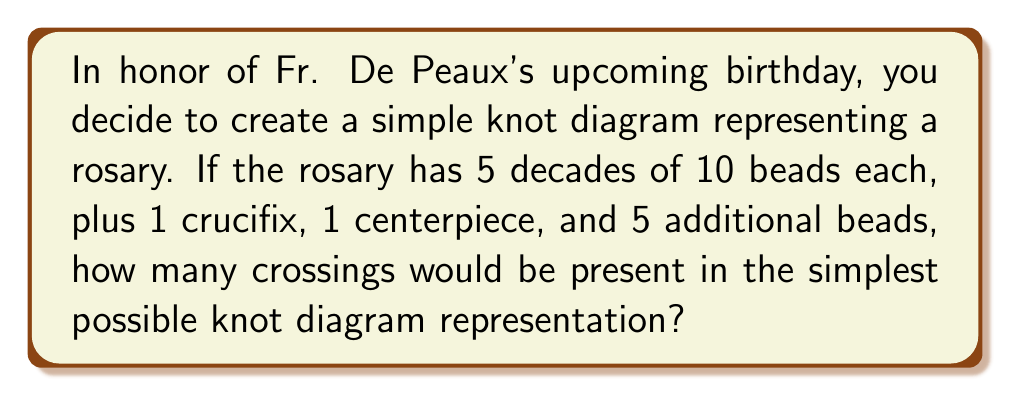Can you solve this math problem? Let's approach this step-by-step:

1) First, we need to calculate the total number of elements in the rosary:
   $$(5 \times 10) + 1 + 1 + 5 = 57$$ elements

2) In knot theory, the simplest representation of a closed loop with multiple elements is a circular diagram.

3) For a circular diagram, the minimum number of crossings is zero, as the loop can be arranged in a planar fashion without any overlaps.

4) However, to represent the rosary's structure accurately, we need to consider the centerpiece, which typically connects the loop at two points.

5) This connection creates two necessary crossings:
   - One where the loop passes behind itself to connect to one side of the centerpiece
   - Another where it passes behind again to connect to the other side

6) No additional crossings are required to represent the beads, crucifix, or decades, as these can be arranged along the circular path without creating overlaps.

Therefore, the simplest possible knot diagram representing this rosary would have 2 crossings.
Answer: 2 crossings 